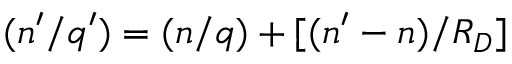<formula> <loc_0><loc_0><loc_500><loc_500>( n ^ { \prime } / q ^ { \prime } ) = ( n / q ) + [ ( n ^ { \prime } - n ) / R _ { D } ]</formula> 